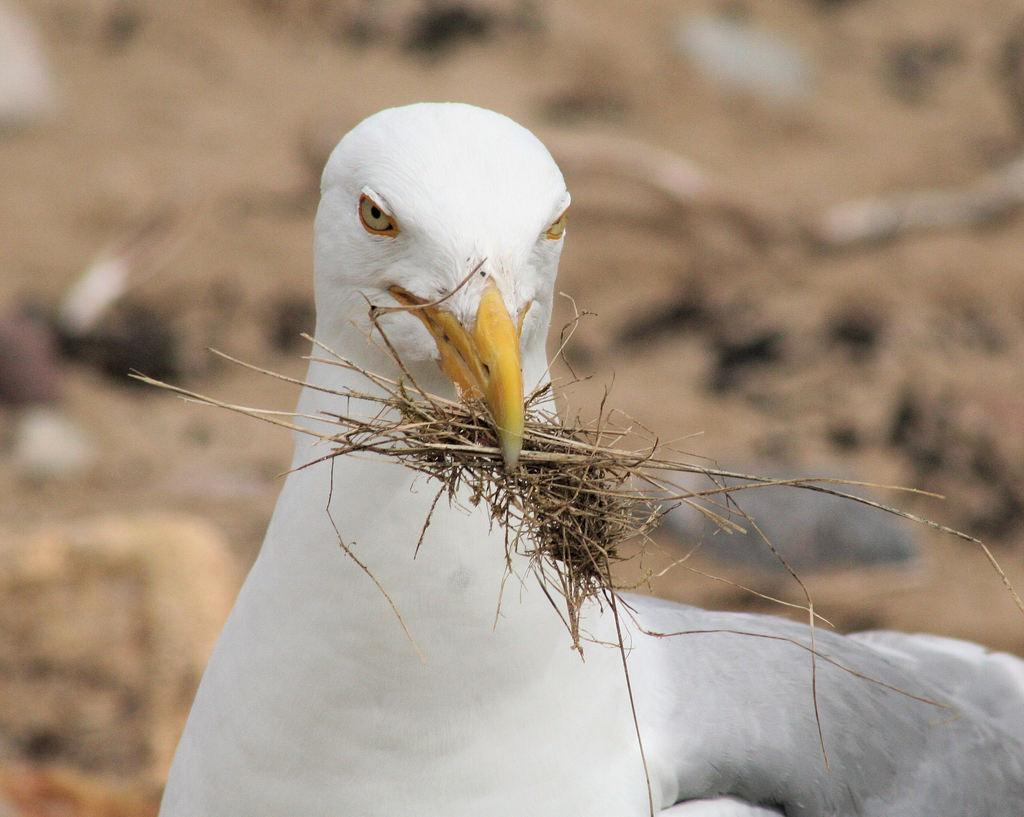What type of animal is present in the image? There is a bird in the image. What is the bird doing in the image? The bird has grass in its beak. Can you describe the background of the image? The background of the image is blurred. What type of government is depicted in the aftermath of the airplane crash in the image? There is no airplane crash or government depicted in the image; it features a bird carrying grass in its beak with a blurred background. 